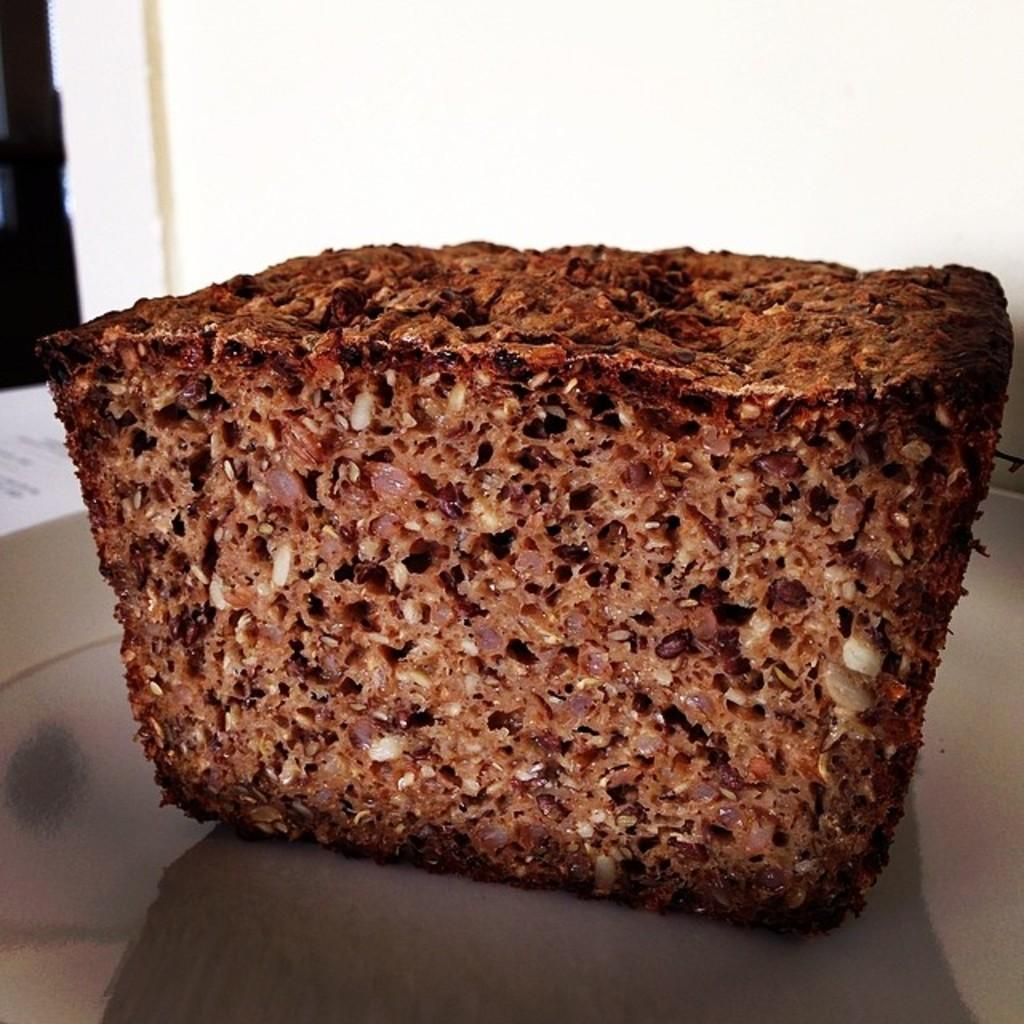What is on the plate in the image? There is a food item on a plate in the image. What can be seen in the background of the image? There is a wall visible in the image. What type of rake is being used to hit the baseball in the image? There is no rake or baseball present in the image. What is the quince doing in the image? There is no quince present in the image. 